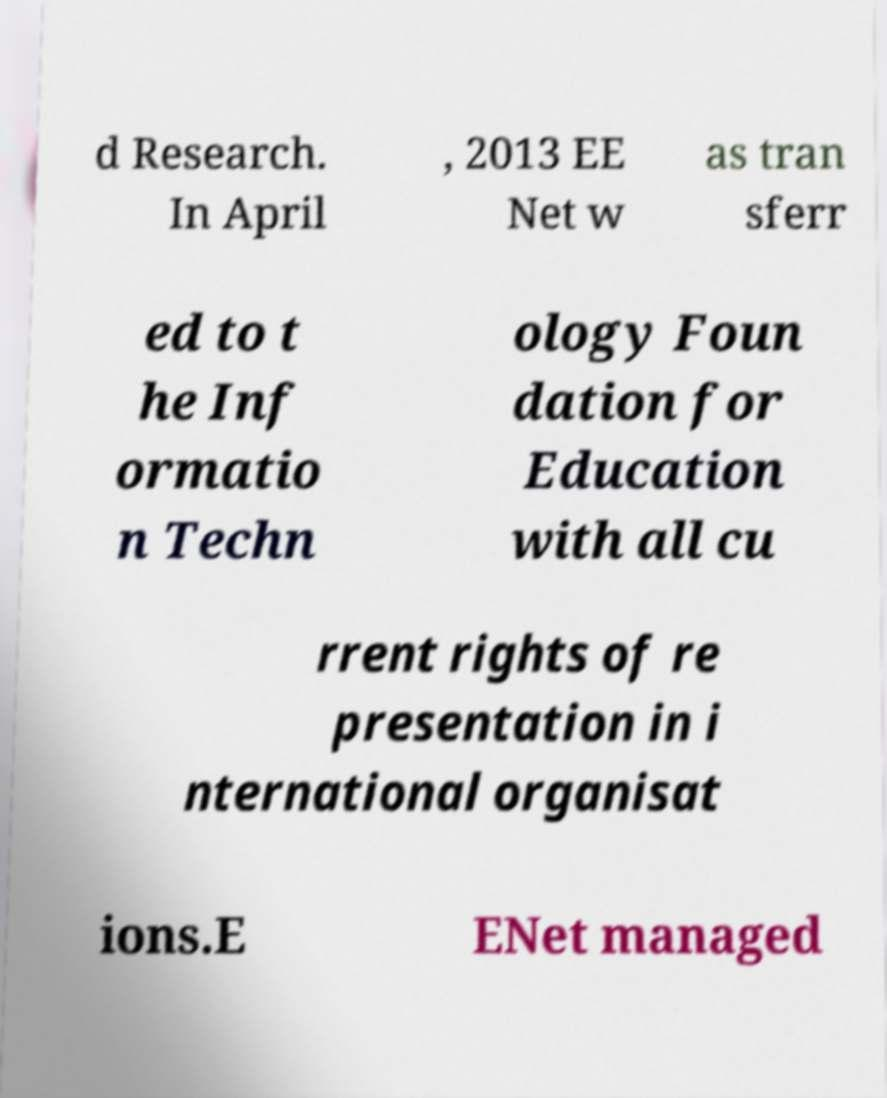For documentation purposes, I need the text within this image transcribed. Could you provide that? d Research. In April , 2013 EE Net w as tran sferr ed to t he Inf ormatio n Techn ology Foun dation for Education with all cu rrent rights of re presentation in i nternational organisat ions.E ENet managed 